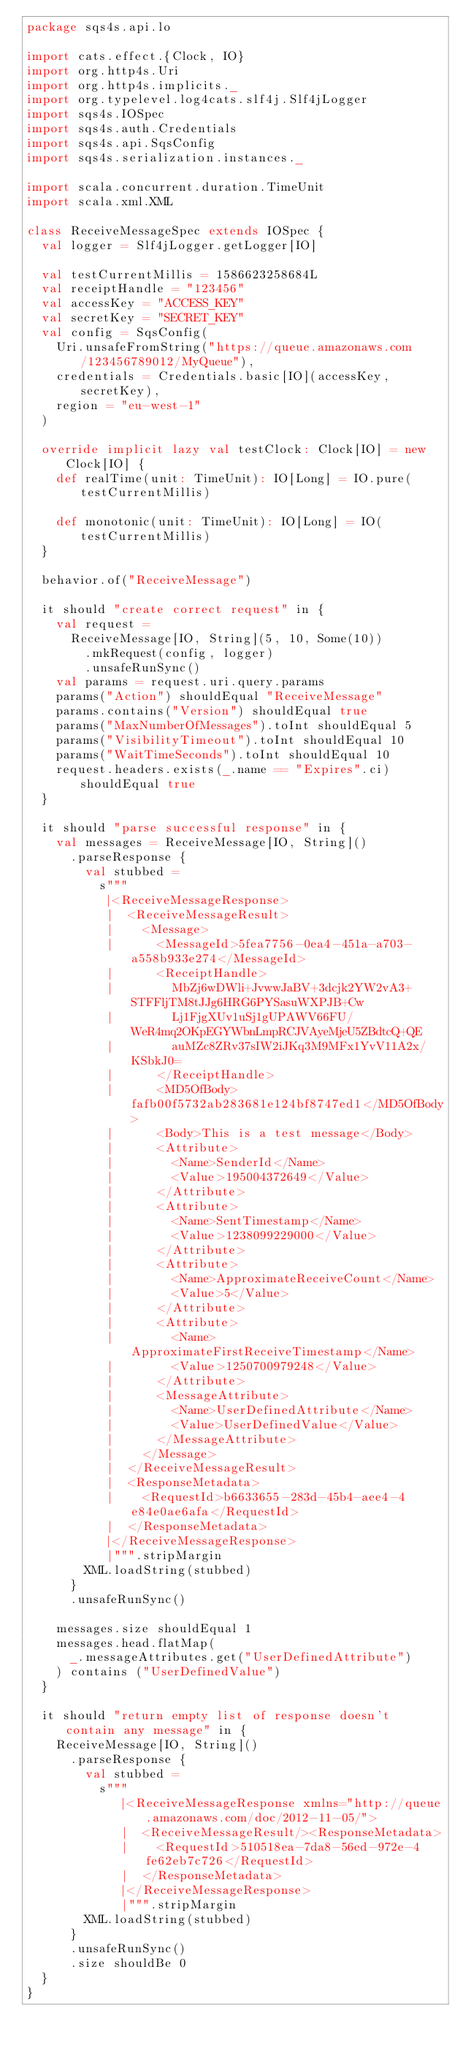<code> <loc_0><loc_0><loc_500><loc_500><_Scala_>package sqs4s.api.lo

import cats.effect.{Clock, IO}
import org.http4s.Uri
import org.http4s.implicits._
import org.typelevel.log4cats.slf4j.Slf4jLogger
import sqs4s.IOSpec
import sqs4s.auth.Credentials
import sqs4s.api.SqsConfig
import sqs4s.serialization.instances._

import scala.concurrent.duration.TimeUnit
import scala.xml.XML

class ReceiveMessageSpec extends IOSpec {
  val logger = Slf4jLogger.getLogger[IO]

  val testCurrentMillis = 1586623258684L
  val receiptHandle = "123456"
  val accessKey = "ACCESS_KEY"
  val secretKey = "SECRET_KEY"
  val config = SqsConfig(
    Uri.unsafeFromString("https://queue.amazonaws.com/123456789012/MyQueue"),
    credentials = Credentials.basic[IO](accessKey, secretKey),
    region = "eu-west-1"
  )

  override implicit lazy val testClock: Clock[IO] = new Clock[IO] {
    def realTime(unit: TimeUnit): IO[Long] = IO.pure(testCurrentMillis)

    def monotonic(unit: TimeUnit): IO[Long] = IO(testCurrentMillis)
  }

  behavior.of("ReceiveMessage")

  it should "create correct request" in {
    val request =
      ReceiveMessage[IO, String](5, 10, Some(10))
        .mkRequest(config, logger)
        .unsafeRunSync()
    val params = request.uri.query.params
    params("Action") shouldEqual "ReceiveMessage"
    params.contains("Version") shouldEqual true
    params("MaxNumberOfMessages").toInt shouldEqual 5
    params("VisibilityTimeout").toInt shouldEqual 10
    params("WaitTimeSeconds").toInt shouldEqual 10
    request.headers.exists(_.name == "Expires".ci) shouldEqual true
  }

  it should "parse successful response" in {
    val messages = ReceiveMessage[IO, String]()
      .parseResponse {
        val stubbed =
          s"""
           |<ReceiveMessageResponse>
           |  <ReceiveMessageResult>
           |    <Message>
           |      <MessageId>5fea7756-0ea4-451a-a703-a558b933e274</MessageId>
           |      <ReceiptHandle>
           |        MbZj6wDWli+JvwwJaBV+3dcjk2YW2vA3+STFFljTM8tJJg6HRG6PYSasuWXPJB+Cw
           |        Lj1FjgXUv1uSj1gUPAWV66FU/WeR4mq2OKpEGYWbnLmpRCJVAyeMjeU5ZBdtcQ+QE
           |        auMZc8ZRv37sIW2iJKq3M9MFx1YvV11A2x/KSbkJ0=
           |      </ReceiptHandle>
           |      <MD5OfBody>fafb00f5732ab283681e124bf8747ed1</MD5OfBody>
           |      <Body>This is a test message</Body>
           |      <Attribute>
           |        <Name>SenderId</Name>
           |        <Value>195004372649</Value>
           |      </Attribute>
           |      <Attribute>
           |        <Name>SentTimestamp</Name>
           |        <Value>1238099229000</Value>
           |      </Attribute>
           |      <Attribute>
           |        <Name>ApproximateReceiveCount</Name>
           |        <Value>5</Value>
           |      </Attribute>
           |      <Attribute>
           |        <Name>ApproximateFirstReceiveTimestamp</Name>
           |        <Value>1250700979248</Value>
           |      </Attribute>
           |      <MessageAttribute>
           |        <Name>UserDefinedAttribute</Name>
           |        <Value>UserDefinedValue</Value>
           |      </MessageAttribute>
           |    </Message>
           |  </ReceiveMessageResult>
           |  <ResponseMetadata>
           |    <RequestId>b6633655-283d-45b4-aee4-4e84e0ae6afa</RequestId>
           |  </ResponseMetadata>
           |</ReceiveMessageResponse>
           |""".stripMargin
        XML.loadString(stubbed)
      }
      .unsafeRunSync()

    messages.size shouldEqual 1
    messages.head.flatMap(
      _.messageAttributes.get("UserDefinedAttribute")
    ) contains ("UserDefinedValue")
  }

  it should "return empty list of response doesn't contain any message" in {
    ReceiveMessage[IO, String]()
      .parseResponse {
        val stubbed =
          s"""
             |<ReceiveMessageResponse xmlns="http://queue.amazonaws.com/doc/2012-11-05/">
             |  <ReceiveMessageResult/><ResponseMetadata>
             |    <RequestId>510518ea-7da8-56ed-972e-4fe62eb7c726</RequestId>
             |  </ResponseMetadata>
             |</ReceiveMessageResponse>
             |""".stripMargin
        XML.loadString(stubbed)
      }
      .unsafeRunSync()
      .size shouldBe 0
  }
}
</code> 